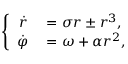Convert formula to latex. <formula><loc_0><loc_0><loc_500><loc_500>\left \{ \begin{array} { r l } { \dot { r } } & = \sigma r \pm r ^ { 3 } , } \\ { \dot { \varphi } } & = \omega + \alpha r ^ { 2 } , } \end{array}</formula> 